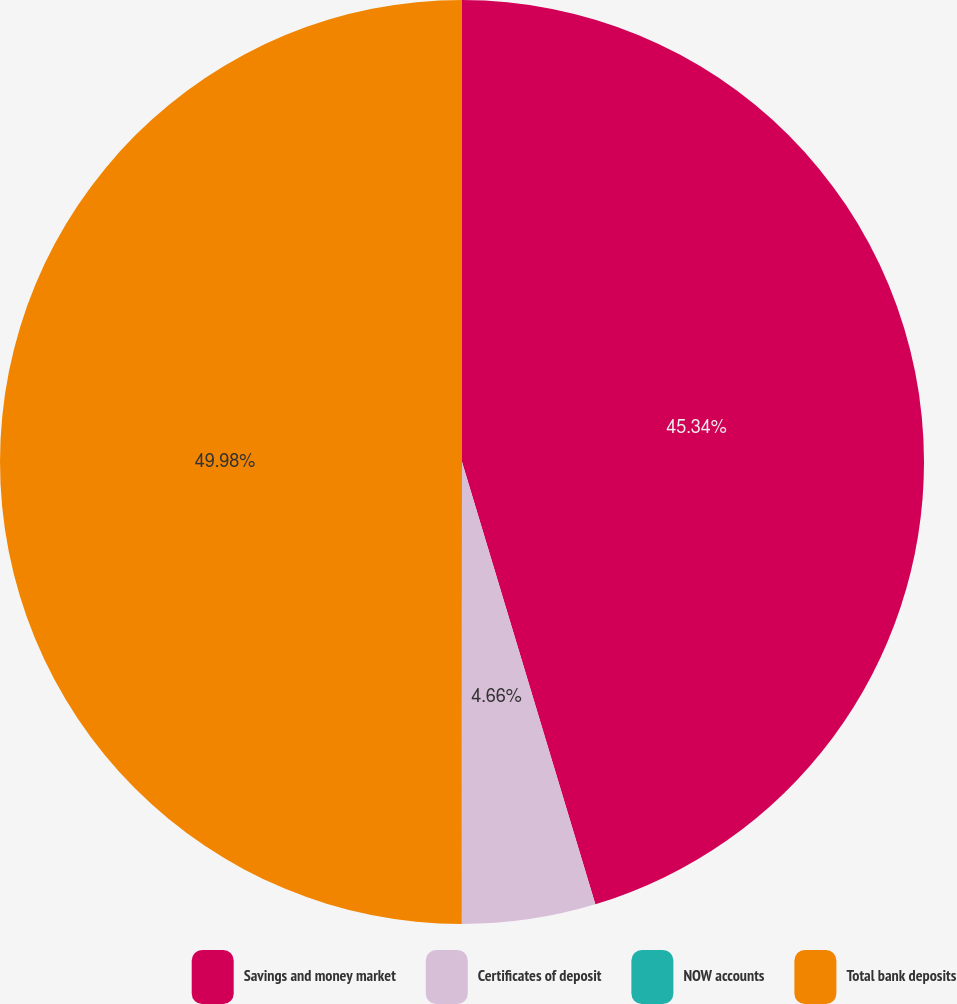<chart> <loc_0><loc_0><loc_500><loc_500><pie_chart><fcel>Savings and money market<fcel>Certificates of deposit<fcel>NOW accounts<fcel>Total bank deposits<nl><fcel>45.34%<fcel>4.66%<fcel>0.02%<fcel>49.98%<nl></chart> 